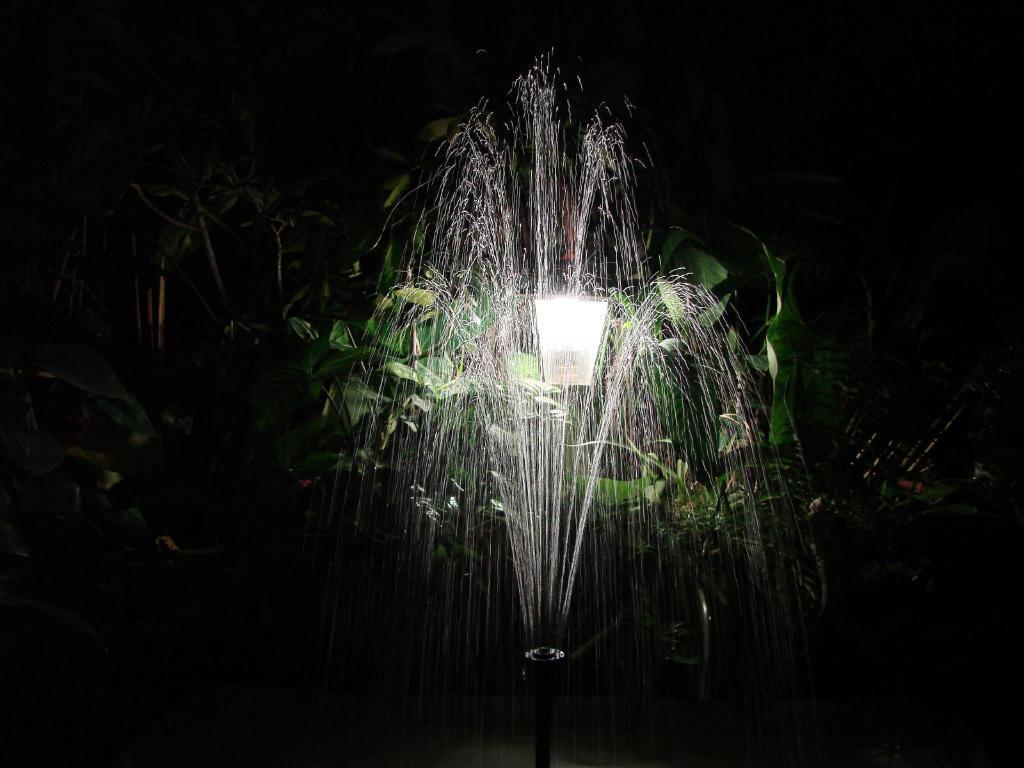Describe this image in one or two sentences. In this picture we can see the water fountain in the front. Behind there is a light shade and some plants. 